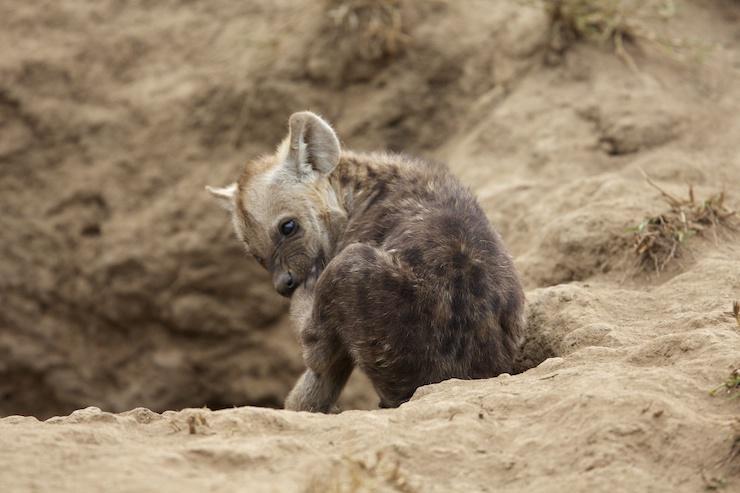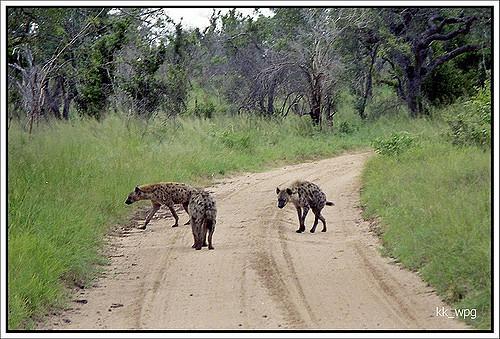The first image is the image on the left, the second image is the image on the right. For the images displayed, is the sentence "One image contains a single hyena." factually correct? Answer yes or no. Yes. 